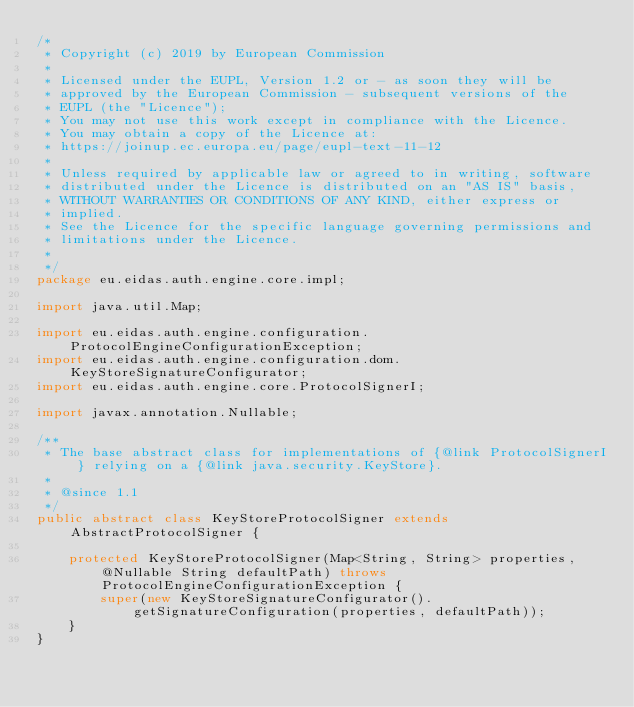Convert code to text. <code><loc_0><loc_0><loc_500><loc_500><_Java_>/*
 * Copyright (c) 2019 by European Commission
 *
 * Licensed under the EUPL, Version 1.2 or - as soon they will be
 * approved by the European Commission - subsequent versions of the
 * EUPL (the "Licence");
 * You may not use this work except in compliance with the Licence.
 * You may obtain a copy of the Licence at:
 * https://joinup.ec.europa.eu/page/eupl-text-11-12
 *
 * Unless required by applicable law or agreed to in writing, software
 * distributed under the Licence is distributed on an "AS IS" basis,
 * WITHOUT WARRANTIES OR CONDITIONS OF ANY KIND, either express or
 * implied.
 * See the Licence for the specific language governing permissions and
 * limitations under the Licence.
 *
 */
package eu.eidas.auth.engine.core.impl;

import java.util.Map;

import eu.eidas.auth.engine.configuration.ProtocolEngineConfigurationException;
import eu.eidas.auth.engine.configuration.dom.KeyStoreSignatureConfigurator;
import eu.eidas.auth.engine.core.ProtocolSignerI;

import javax.annotation.Nullable;

/**
 * The base abstract class for implementations of {@link ProtocolSignerI} relying on a {@link java.security.KeyStore}.
 *
 * @since 1.1
 */
public abstract class KeyStoreProtocolSigner extends AbstractProtocolSigner {

    protected KeyStoreProtocolSigner(Map<String, String> properties, @Nullable String defaultPath) throws ProtocolEngineConfigurationException {
        super(new KeyStoreSignatureConfigurator().getSignatureConfiguration(properties, defaultPath));
    }
}
</code> 